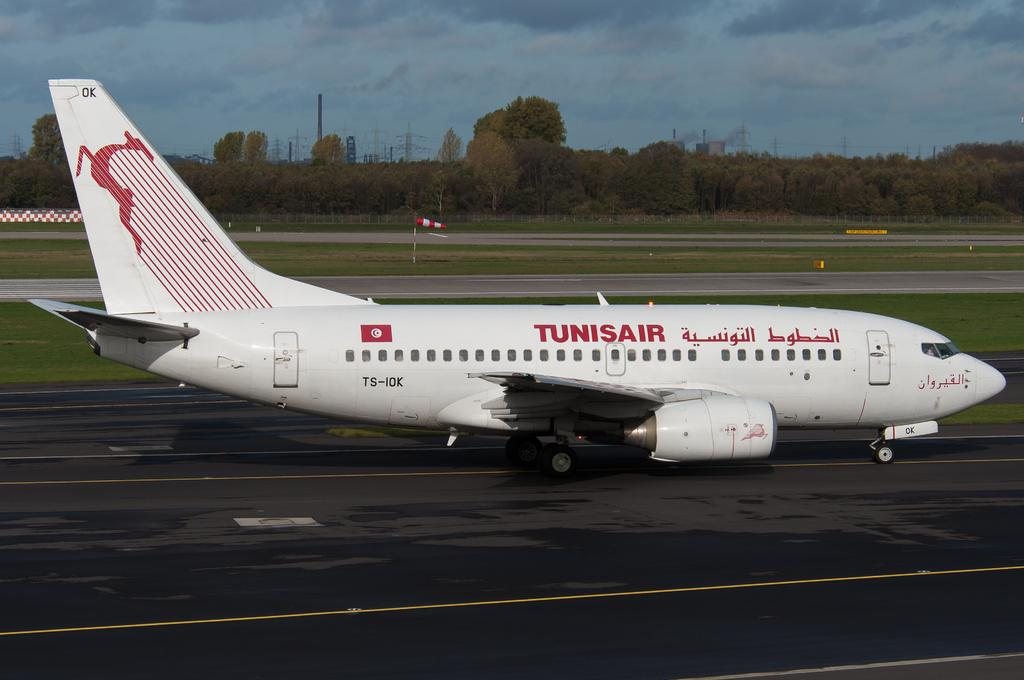What is the main subject of the image? The main subject of the image is an airplane. What else can be seen in the image besides the airplane? There is a road, grass, trees, electric poles, and a cloudy sky visible in the image. What statement or advice is being given by the sack in the image? There is no sack present in the image, so no statement or advice can be attributed to it. 